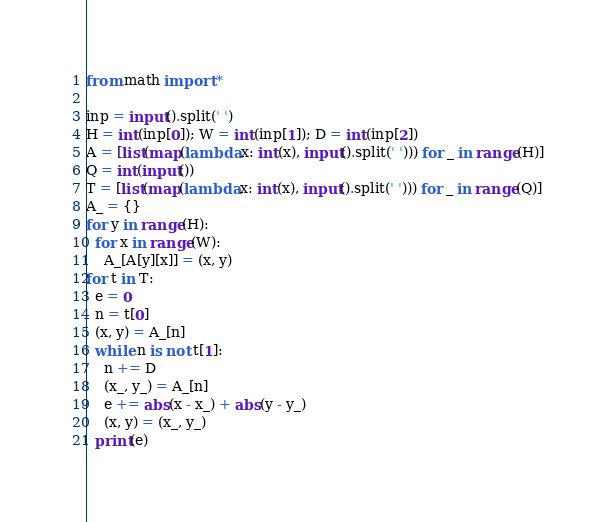Convert code to text. <code><loc_0><loc_0><loc_500><loc_500><_Python_>from math import *

inp = input().split(' ')
H = int(inp[0]); W = int(inp[1]); D = int(inp[2])
A = [list(map(lambda x: int(x), input().split(' '))) for _ in range(H)]
Q = int(input())
T = [list(map(lambda x: int(x), input().split(' '))) for _ in range(Q)]
A_ = {}
for y in range(H):
  for x in range(W):
    A_[A[y][x]] = (x, y)
for t in T:
  e = 0
  n = t[0]
  (x, y) = A_[n]
  while n is not t[1]:
    n += D
    (x_, y_) = A_[n]
    e += abs(x - x_) + abs(y - y_)
    (x, y) = (x_, y_)
  print(e)

</code> 